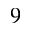<formula> <loc_0><loc_0><loc_500><loc_500>^ { 9 }</formula> 